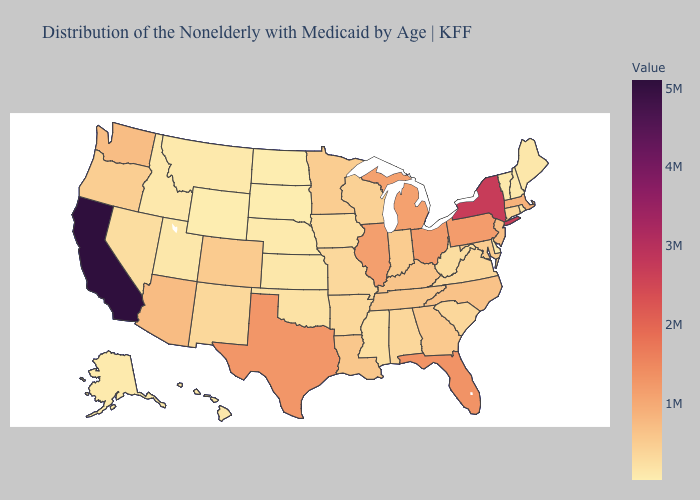Does Utah have the lowest value in the USA?
Concise answer only. No. Does Rhode Island have the lowest value in the Northeast?
Be succinct. No. Does California have the highest value in the West?
Quick response, please. Yes. Among the states that border Minnesota , does Wisconsin have the highest value?
Short answer required. Yes. Does Hawaii have the lowest value in the West?
Concise answer only. No. Does Wyoming have the lowest value in the USA?
Answer briefly. Yes. Among the states that border Ohio , which have the highest value?
Answer briefly. Pennsylvania. 